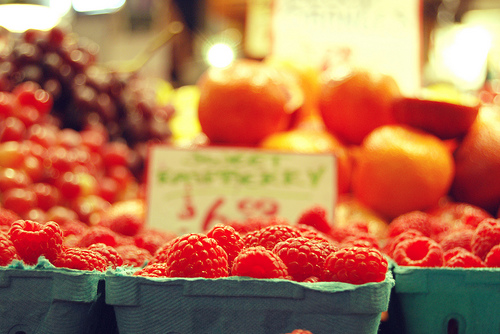<image>
Can you confirm if the apple is behind the raspberry? Yes. From this viewpoint, the apple is positioned behind the raspberry, with the raspberry partially or fully occluding the apple. 